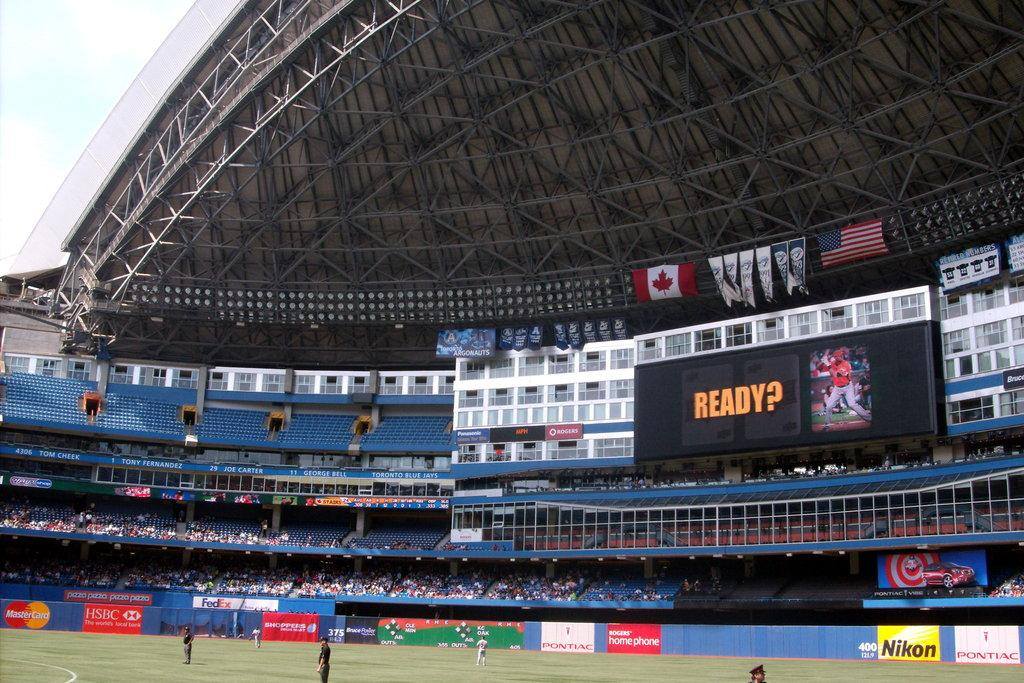<image>
Offer a succinct explanation of the picture presented. a scoreboard inside of an arena that says 'ready?' 